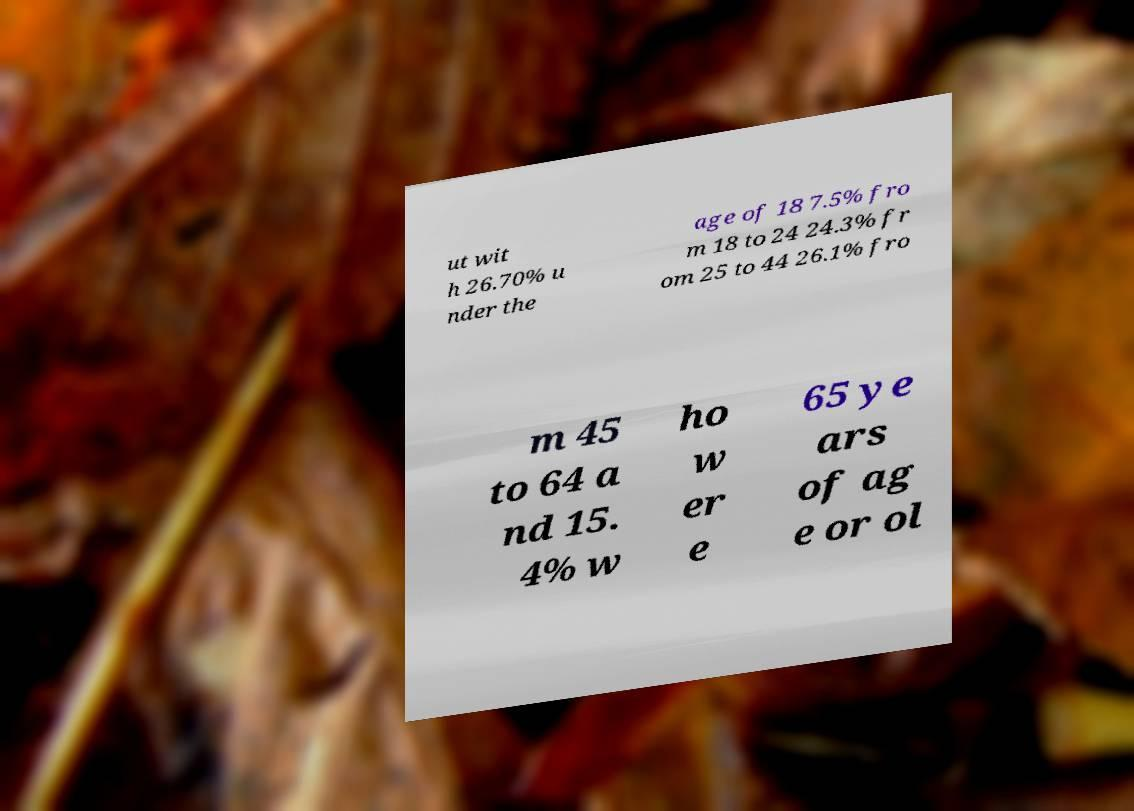Please identify and transcribe the text found in this image. ut wit h 26.70% u nder the age of 18 7.5% fro m 18 to 24 24.3% fr om 25 to 44 26.1% fro m 45 to 64 a nd 15. 4% w ho w er e 65 ye ars of ag e or ol 